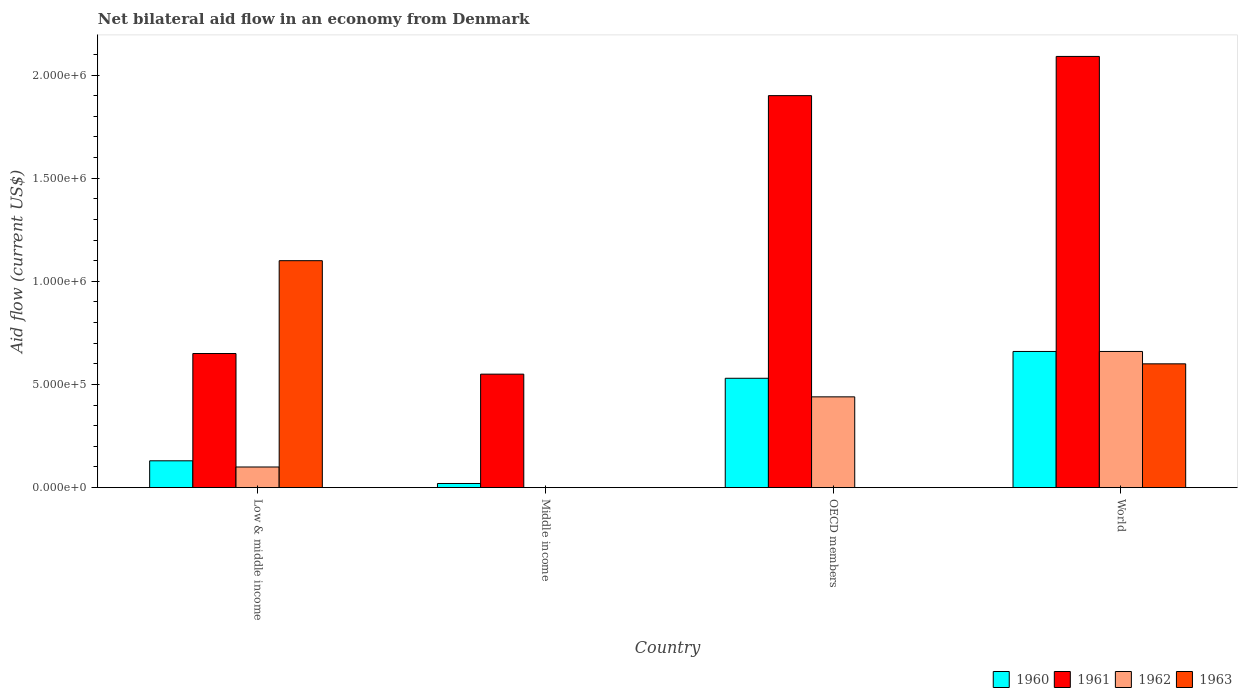How many groups of bars are there?
Your response must be concise. 4. How many bars are there on the 3rd tick from the left?
Keep it short and to the point. 3. What is the label of the 3rd group of bars from the left?
Provide a succinct answer. OECD members. What is the net bilateral aid flow in 1963 in Low & middle income?
Provide a succinct answer. 1.10e+06. Across all countries, what is the maximum net bilateral aid flow in 1961?
Your answer should be very brief. 2.09e+06. In which country was the net bilateral aid flow in 1963 maximum?
Make the answer very short. Low & middle income. What is the total net bilateral aid flow in 1962 in the graph?
Offer a very short reply. 1.20e+06. What is the difference between the net bilateral aid flow in 1961 in Low & middle income and that in Middle income?
Your answer should be compact. 1.00e+05. What is the difference between the net bilateral aid flow in 1963 in Low & middle income and the net bilateral aid flow in 1961 in Middle income?
Ensure brevity in your answer.  5.50e+05. What is the difference between the net bilateral aid flow of/in 1960 and net bilateral aid flow of/in 1961 in Low & middle income?
Make the answer very short. -5.20e+05. What is the ratio of the net bilateral aid flow in 1962 in OECD members to that in World?
Your answer should be compact. 0.67. Is the difference between the net bilateral aid flow in 1960 in Low & middle income and World greater than the difference between the net bilateral aid flow in 1961 in Low & middle income and World?
Keep it short and to the point. Yes. What is the difference between the highest and the second highest net bilateral aid flow in 1960?
Make the answer very short. 1.30e+05. What is the difference between the highest and the lowest net bilateral aid flow in 1960?
Give a very brief answer. 6.40e+05. Is the sum of the net bilateral aid flow in 1962 in Low & middle income and OECD members greater than the maximum net bilateral aid flow in 1961 across all countries?
Make the answer very short. No. Is it the case that in every country, the sum of the net bilateral aid flow in 1961 and net bilateral aid flow in 1960 is greater than the net bilateral aid flow in 1963?
Your response must be concise. No. Are all the bars in the graph horizontal?
Your response must be concise. No. Are the values on the major ticks of Y-axis written in scientific E-notation?
Your answer should be very brief. Yes. How many legend labels are there?
Provide a short and direct response. 4. What is the title of the graph?
Provide a short and direct response. Net bilateral aid flow in an economy from Denmark. What is the label or title of the X-axis?
Offer a terse response. Country. What is the Aid flow (current US$) in 1961 in Low & middle income?
Your answer should be very brief. 6.50e+05. What is the Aid flow (current US$) in 1962 in Low & middle income?
Your answer should be compact. 1.00e+05. What is the Aid flow (current US$) in 1963 in Low & middle income?
Offer a very short reply. 1.10e+06. What is the Aid flow (current US$) of 1960 in Middle income?
Ensure brevity in your answer.  2.00e+04. What is the Aid flow (current US$) of 1962 in Middle income?
Provide a succinct answer. 0. What is the Aid flow (current US$) in 1960 in OECD members?
Ensure brevity in your answer.  5.30e+05. What is the Aid flow (current US$) of 1961 in OECD members?
Provide a short and direct response. 1.90e+06. What is the Aid flow (current US$) in 1962 in OECD members?
Your response must be concise. 4.40e+05. What is the Aid flow (current US$) in 1963 in OECD members?
Ensure brevity in your answer.  0. What is the Aid flow (current US$) of 1961 in World?
Give a very brief answer. 2.09e+06. What is the Aid flow (current US$) in 1963 in World?
Give a very brief answer. 6.00e+05. Across all countries, what is the maximum Aid flow (current US$) in 1960?
Your response must be concise. 6.60e+05. Across all countries, what is the maximum Aid flow (current US$) in 1961?
Provide a short and direct response. 2.09e+06. Across all countries, what is the maximum Aid flow (current US$) in 1962?
Your answer should be compact. 6.60e+05. Across all countries, what is the maximum Aid flow (current US$) in 1963?
Make the answer very short. 1.10e+06. What is the total Aid flow (current US$) of 1960 in the graph?
Your answer should be compact. 1.34e+06. What is the total Aid flow (current US$) in 1961 in the graph?
Keep it short and to the point. 5.19e+06. What is the total Aid flow (current US$) in 1962 in the graph?
Offer a very short reply. 1.20e+06. What is the total Aid flow (current US$) of 1963 in the graph?
Your answer should be compact. 1.70e+06. What is the difference between the Aid flow (current US$) of 1960 in Low & middle income and that in Middle income?
Give a very brief answer. 1.10e+05. What is the difference between the Aid flow (current US$) of 1960 in Low & middle income and that in OECD members?
Offer a terse response. -4.00e+05. What is the difference between the Aid flow (current US$) of 1961 in Low & middle income and that in OECD members?
Offer a terse response. -1.25e+06. What is the difference between the Aid flow (current US$) in 1960 in Low & middle income and that in World?
Provide a succinct answer. -5.30e+05. What is the difference between the Aid flow (current US$) in 1961 in Low & middle income and that in World?
Offer a very short reply. -1.44e+06. What is the difference between the Aid flow (current US$) in 1962 in Low & middle income and that in World?
Ensure brevity in your answer.  -5.60e+05. What is the difference between the Aid flow (current US$) of 1960 in Middle income and that in OECD members?
Provide a succinct answer. -5.10e+05. What is the difference between the Aid flow (current US$) in 1961 in Middle income and that in OECD members?
Your answer should be compact. -1.35e+06. What is the difference between the Aid flow (current US$) in 1960 in Middle income and that in World?
Give a very brief answer. -6.40e+05. What is the difference between the Aid flow (current US$) in 1961 in Middle income and that in World?
Your answer should be compact. -1.54e+06. What is the difference between the Aid flow (current US$) of 1960 in OECD members and that in World?
Ensure brevity in your answer.  -1.30e+05. What is the difference between the Aid flow (current US$) in 1961 in OECD members and that in World?
Make the answer very short. -1.90e+05. What is the difference between the Aid flow (current US$) of 1962 in OECD members and that in World?
Offer a terse response. -2.20e+05. What is the difference between the Aid flow (current US$) in 1960 in Low & middle income and the Aid flow (current US$) in 1961 in Middle income?
Your answer should be very brief. -4.20e+05. What is the difference between the Aid flow (current US$) in 1960 in Low & middle income and the Aid flow (current US$) in 1961 in OECD members?
Provide a short and direct response. -1.77e+06. What is the difference between the Aid flow (current US$) in 1960 in Low & middle income and the Aid flow (current US$) in 1962 in OECD members?
Ensure brevity in your answer.  -3.10e+05. What is the difference between the Aid flow (current US$) of 1961 in Low & middle income and the Aid flow (current US$) of 1962 in OECD members?
Keep it short and to the point. 2.10e+05. What is the difference between the Aid flow (current US$) of 1960 in Low & middle income and the Aid flow (current US$) of 1961 in World?
Provide a short and direct response. -1.96e+06. What is the difference between the Aid flow (current US$) in 1960 in Low & middle income and the Aid flow (current US$) in 1962 in World?
Offer a very short reply. -5.30e+05. What is the difference between the Aid flow (current US$) of 1960 in Low & middle income and the Aid flow (current US$) of 1963 in World?
Your answer should be very brief. -4.70e+05. What is the difference between the Aid flow (current US$) of 1961 in Low & middle income and the Aid flow (current US$) of 1963 in World?
Your answer should be very brief. 5.00e+04. What is the difference between the Aid flow (current US$) in 1962 in Low & middle income and the Aid flow (current US$) in 1963 in World?
Make the answer very short. -5.00e+05. What is the difference between the Aid flow (current US$) in 1960 in Middle income and the Aid flow (current US$) in 1961 in OECD members?
Offer a very short reply. -1.88e+06. What is the difference between the Aid flow (current US$) of 1960 in Middle income and the Aid flow (current US$) of 1962 in OECD members?
Ensure brevity in your answer.  -4.20e+05. What is the difference between the Aid flow (current US$) in 1961 in Middle income and the Aid flow (current US$) in 1962 in OECD members?
Make the answer very short. 1.10e+05. What is the difference between the Aid flow (current US$) of 1960 in Middle income and the Aid flow (current US$) of 1961 in World?
Ensure brevity in your answer.  -2.07e+06. What is the difference between the Aid flow (current US$) in 1960 in Middle income and the Aid flow (current US$) in 1962 in World?
Your response must be concise. -6.40e+05. What is the difference between the Aid flow (current US$) of 1960 in Middle income and the Aid flow (current US$) of 1963 in World?
Offer a terse response. -5.80e+05. What is the difference between the Aid flow (current US$) in 1961 in Middle income and the Aid flow (current US$) in 1962 in World?
Keep it short and to the point. -1.10e+05. What is the difference between the Aid flow (current US$) of 1961 in Middle income and the Aid flow (current US$) of 1963 in World?
Make the answer very short. -5.00e+04. What is the difference between the Aid flow (current US$) in 1960 in OECD members and the Aid flow (current US$) in 1961 in World?
Your answer should be very brief. -1.56e+06. What is the difference between the Aid flow (current US$) of 1960 in OECD members and the Aid flow (current US$) of 1962 in World?
Provide a succinct answer. -1.30e+05. What is the difference between the Aid flow (current US$) of 1960 in OECD members and the Aid flow (current US$) of 1963 in World?
Provide a short and direct response. -7.00e+04. What is the difference between the Aid flow (current US$) of 1961 in OECD members and the Aid flow (current US$) of 1962 in World?
Provide a succinct answer. 1.24e+06. What is the difference between the Aid flow (current US$) of 1961 in OECD members and the Aid flow (current US$) of 1963 in World?
Your answer should be very brief. 1.30e+06. What is the difference between the Aid flow (current US$) of 1962 in OECD members and the Aid flow (current US$) of 1963 in World?
Your answer should be compact. -1.60e+05. What is the average Aid flow (current US$) of 1960 per country?
Offer a terse response. 3.35e+05. What is the average Aid flow (current US$) in 1961 per country?
Offer a very short reply. 1.30e+06. What is the average Aid flow (current US$) in 1962 per country?
Make the answer very short. 3.00e+05. What is the average Aid flow (current US$) of 1963 per country?
Offer a terse response. 4.25e+05. What is the difference between the Aid flow (current US$) of 1960 and Aid flow (current US$) of 1961 in Low & middle income?
Your response must be concise. -5.20e+05. What is the difference between the Aid flow (current US$) in 1960 and Aid flow (current US$) in 1963 in Low & middle income?
Your answer should be compact. -9.70e+05. What is the difference between the Aid flow (current US$) of 1961 and Aid flow (current US$) of 1963 in Low & middle income?
Offer a very short reply. -4.50e+05. What is the difference between the Aid flow (current US$) of 1962 and Aid flow (current US$) of 1963 in Low & middle income?
Your answer should be very brief. -1.00e+06. What is the difference between the Aid flow (current US$) of 1960 and Aid flow (current US$) of 1961 in Middle income?
Offer a terse response. -5.30e+05. What is the difference between the Aid flow (current US$) of 1960 and Aid flow (current US$) of 1961 in OECD members?
Your response must be concise. -1.37e+06. What is the difference between the Aid flow (current US$) in 1961 and Aid flow (current US$) in 1962 in OECD members?
Your answer should be compact. 1.46e+06. What is the difference between the Aid flow (current US$) in 1960 and Aid flow (current US$) in 1961 in World?
Give a very brief answer. -1.43e+06. What is the difference between the Aid flow (current US$) of 1960 and Aid flow (current US$) of 1962 in World?
Provide a short and direct response. 0. What is the difference between the Aid flow (current US$) in 1960 and Aid flow (current US$) in 1963 in World?
Keep it short and to the point. 6.00e+04. What is the difference between the Aid flow (current US$) of 1961 and Aid flow (current US$) of 1962 in World?
Offer a terse response. 1.43e+06. What is the difference between the Aid flow (current US$) in 1961 and Aid flow (current US$) in 1963 in World?
Give a very brief answer. 1.49e+06. What is the difference between the Aid flow (current US$) of 1962 and Aid flow (current US$) of 1963 in World?
Give a very brief answer. 6.00e+04. What is the ratio of the Aid flow (current US$) of 1960 in Low & middle income to that in Middle income?
Your response must be concise. 6.5. What is the ratio of the Aid flow (current US$) of 1961 in Low & middle income to that in Middle income?
Make the answer very short. 1.18. What is the ratio of the Aid flow (current US$) of 1960 in Low & middle income to that in OECD members?
Your answer should be very brief. 0.25. What is the ratio of the Aid flow (current US$) in 1961 in Low & middle income to that in OECD members?
Provide a short and direct response. 0.34. What is the ratio of the Aid flow (current US$) of 1962 in Low & middle income to that in OECD members?
Provide a short and direct response. 0.23. What is the ratio of the Aid flow (current US$) in 1960 in Low & middle income to that in World?
Keep it short and to the point. 0.2. What is the ratio of the Aid flow (current US$) in 1961 in Low & middle income to that in World?
Give a very brief answer. 0.31. What is the ratio of the Aid flow (current US$) of 1962 in Low & middle income to that in World?
Your response must be concise. 0.15. What is the ratio of the Aid flow (current US$) in 1963 in Low & middle income to that in World?
Offer a terse response. 1.83. What is the ratio of the Aid flow (current US$) of 1960 in Middle income to that in OECD members?
Provide a succinct answer. 0.04. What is the ratio of the Aid flow (current US$) in 1961 in Middle income to that in OECD members?
Offer a terse response. 0.29. What is the ratio of the Aid flow (current US$) of 1960 in Middle income to that in World?
Make the answer very short. 0.03. What is the ratio of the Aid flow (current US$) in 1961 in Middle income to that in World?
Provide a short and direct response. 0.26. What is the ratio of the Aid flow (current US$) in 1960 in OECD members to that in World?
Provide a succinct answer. 0.8. What is the difference between the highest and the second highest Aid flow (current US$) of 1960?
Keep it short and to the point. 1.30e+05. What is the difference between the highest and the second highest Aid flow (current US$) of 1961?
Your answer should be very brief. 1.90e+05. What is the difference between the highest and the second highest Aid flow (current US$) of 1962?
Your answer should be compact. 2.20e+05. What is the difference between the highest and the lowest Aid flow (current US$) in 1960?
Offer a terse response. 6.40e+05. What is the difference between the highest and the lowest Aid flow (current US$) of 1961?
Your response must be concise. 1.54e+06. What is the difference between the highest and the lowest Aid flow (current US$) in 1963?
Your answer should be very brief. 1.10e+06. 